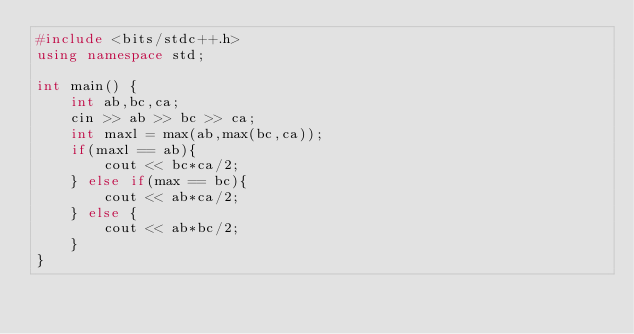Convert code to text. <code><loc_0><loc_0><loc_500><loc_500><_C++_>#include <bits/stdc++.h>
using namespace std;

int main() {
    int ab,bc,ca;
    cin >> ab >> bc >> ca;
    int maxl = max(ab,max(bc,ca));
    if(maxl == ab){
        cout << bc*ca/2;
    } else if(max == bc){
        cout << ab*ca/2;
    } else {
        cout << ab*bc/2;
    }
}</code> 